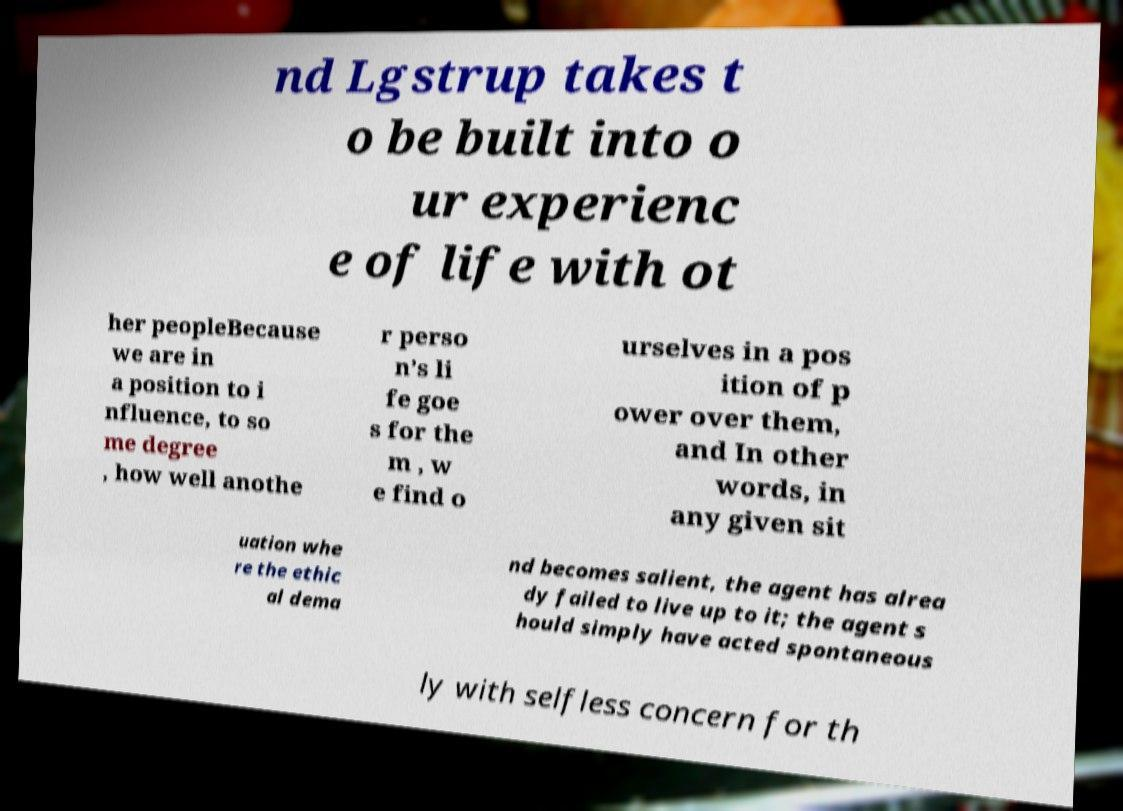Can you accurately transcribe the text from the provided image for me? nd Lgstrup takes t o be built into o ur experienc e of life with ot her peopleBecause we are in a position to i nfluence, to so me degree , how well anothe r perso n’s li fe goe s for the m , w e find o urselves in a pos ition of p ower over them, and In other words, in any given sit uation whe re the ethic al dema nd becomes salient, the agent has alrea dy failed to live up to it; the agent s hould simply have acted spontaneous ly with selfless concern for th 